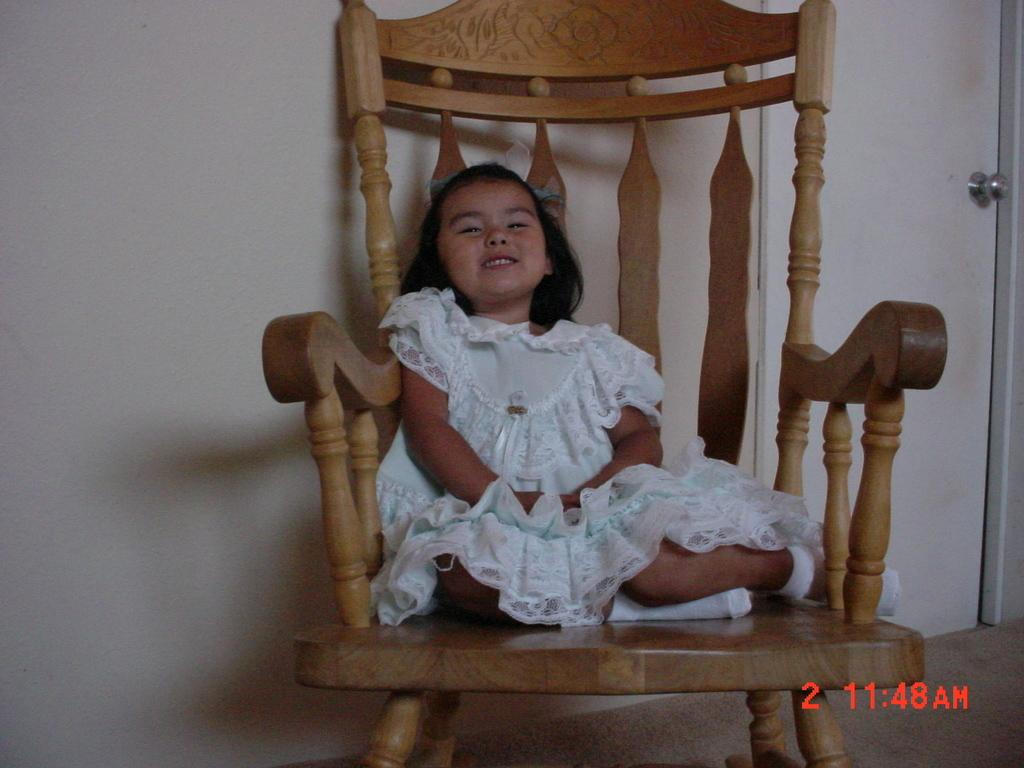Who is the main subject in the image? There is a girl in the image. What is the girl doing in the image? The girl is sitting on a chair and laughing. What can be seen in the background of the image? There is a wall and a door in the background of the image. What type of territory is the girl claiming in the image? There is no indication of the girl claiming any territory in the image. What instrument is the girl playing in the image? There is no instrument, such as a drum, present in the image. 